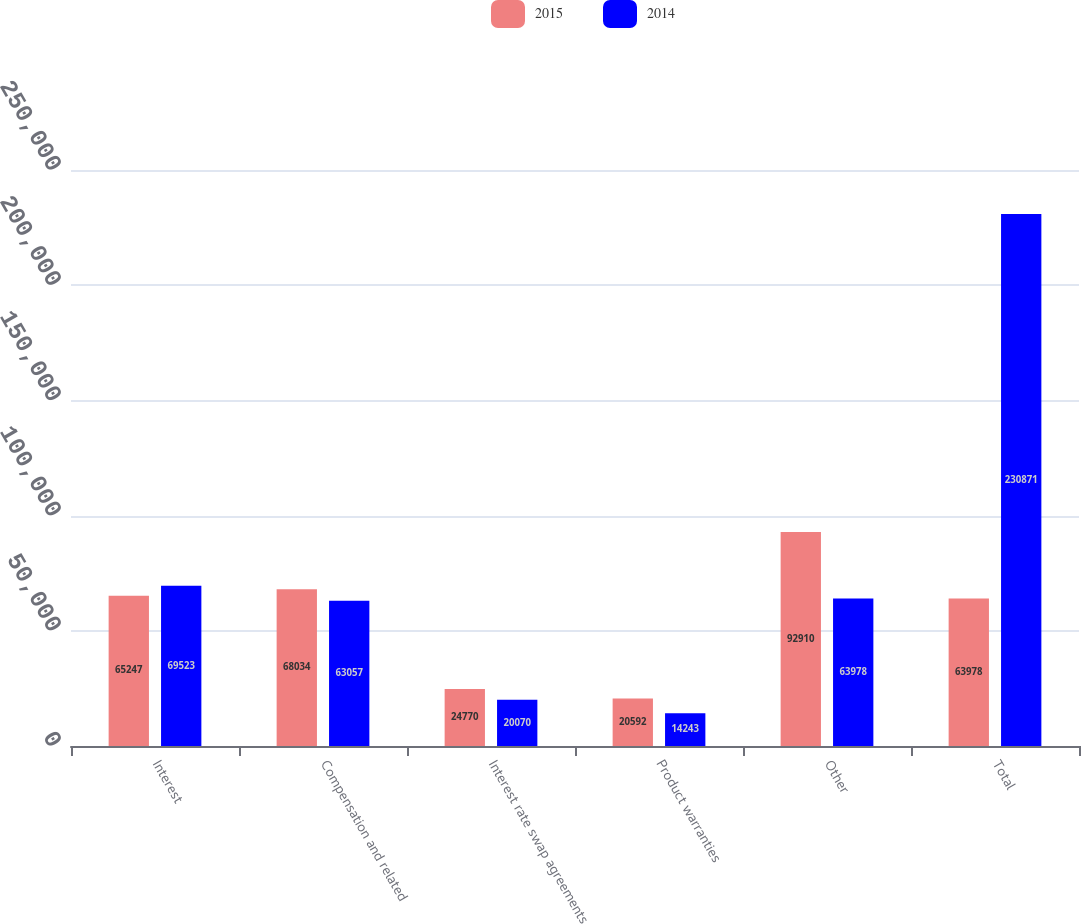Convert chart. <chart><loc_0><loc_0><loc_500><loc_500><stacked_bar_chart><ecel><fcel>Interest<fcel>Compensation and related<fcel>Interest rate swap agreements<fcel>Product warranties<fcel>Other<fcel>Total<nl><fcel>2015<fcel>65247<fcel>68034<fcel>24770<fcel>20592<fcel>92910<fcel>63978<nl><fcel>2014<fcel>69523<fcel>63057<fcel>20070<fcel>14243<fcel>63978<fcel>230871<nl></chart> 